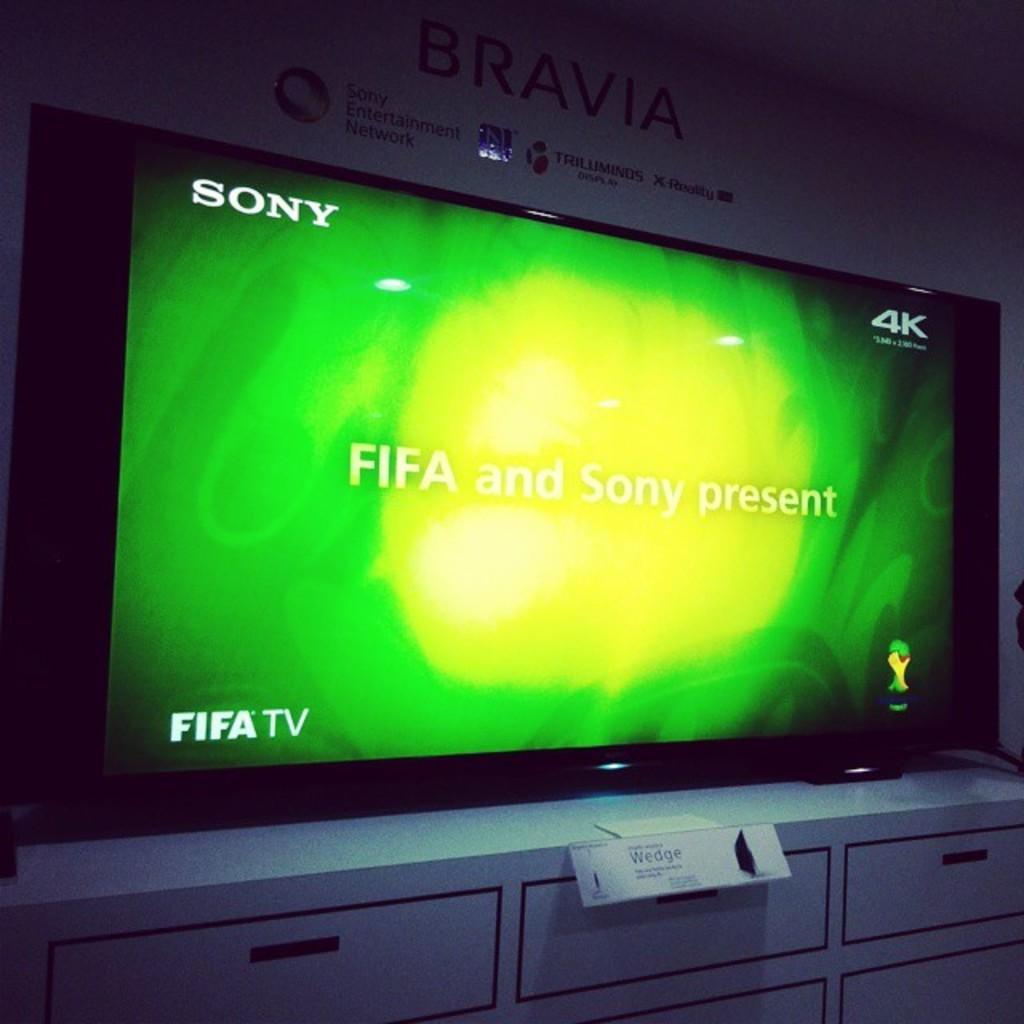How would you summarize this image in a sentence or two? In the picture I can see a television is placed on the white color surface. Here we can see a green color image is displayed on it and in the background, I can see the board on which I can see some text. 